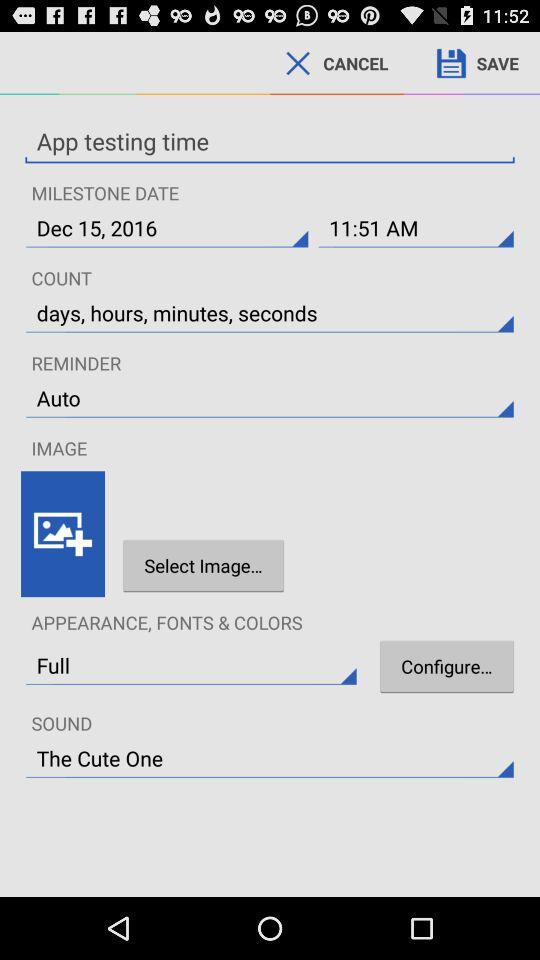What is the given time for the milestone? The given time is 11:51 AM. 